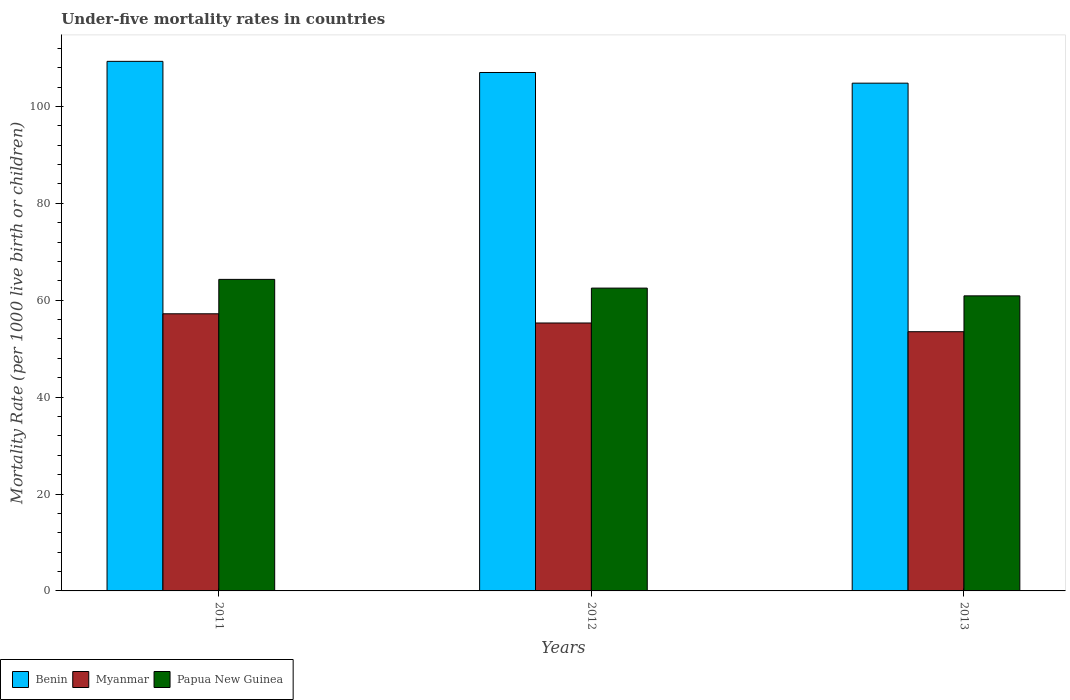How many different coloured bars are there?
Your response must be concise. 3. Are the number of bars on each tick of the X-axis equal?
Your answer should be compact. Yes. How many bars are there on the 2nd tick from the left?
Make the answer very short. 3. How many bars are there on the 3rd tick from the right?
Offer a very short reply. 3. What is the under-five mortality rate in Benin in 2011?
Provide a succinct answer. 109.3. Across all years, what is the maximum under-five mortality rate in Benin?
Keep it short and to the point. 109.3. Across all years, what is the minimum under-five mortality rate in Myanmar?
Your response must be concise. 53.5. In which year was the under-five mortality rate in Papua New Guinea maximum?
Ensure brevity in your answer.  2011. What is the total under-five mortality rate in Papua New Guinea in the graph?
Provide a short and direct response. 187.7. What is the difference between the under-five mortality rate in Benin in 2012 and that in 2013?
Offer a terse response. 2.2. What is the difference between the under-five mortality rate in Papua New Guinea in 2011 and the under-five mortality rate in Myanmar in 2013?
Provide a succinct answer. 10.8. What is the average under-five mortality rate in Papua New Guinea per year?
Make the answer very short. 62.57. In the year 2013, what is the difference between the under-five mortality rate in Papua New Guinea and under-five mortality rate in Benin?
Offer a terse response. -43.9. What is the ratio of the under-five mortality rate in Benin in 2011 to that in 2013?
Ensure brevity in your answer.  1.04. What is the difference between the highest and the second highest under-five mortality rate in Papua New Guinea?
Offer a very short reply. 1.8. What is the difference between the highest and the lowest under-five mortality rate in Papua New Guinea?
Offer a terse response. 3.4. In how many years, is the under-five mortality rate in Benin greater than the average under-five mortality rate in Benin taken over all years?
Offer a terse response. 1. Is the sum of the under-five mortality rate in Myanmar in 2011 and 2012 greater than the maximum under-five mortality rate in Benin across all years?
Keep it short and to the point. Yes. What does the 2nd bar from the left in 2011 represents?
Make the answer very short. Myanmar. What does the 3rd bar from the right in 2013 represents?
Give a very brief answer. Benin. Are all the bars in the graph horizontal?
Offer a terse response. No. Are the values on the major ticks of Y-axis written in scientific E-notation?
Provide a succinct answer. No. Does the graph contain any zero values?
Offer a terse response. No. Does the graph contain grids?
Your response must be concise. No. How many legend labels are there?
Your response must be concise. 3. How are the legend labels stacked?
Provide a short and direct response. Horizontal. What is the title of the graph?
Provide a short and direct response. Under-five mortality rates in countries. Does "Antigua and Barbuda" appear as one of the legend labels in the graph?
Give a very brief answer. No. What is the label or title of the Y-axis?
Provide a succinct answer. Mortality Rate (per 1000 live birth or children). What is the Mortality Rate (per 1000 live birth or children) of Benin in 2011?
Ensure brevity in your answer.  109.3. What is the Mortality Rate (per 1000 live birth or children) of Myanmar in 2011?
Ensure brevity in your answer.  57.2. What is the Mortality Rate (per 1000 live birth or children) of Papua New Guinea in 2011?
Your answer should be very brief. 64.3. What is the Mortality Rate (per 1000 live birth or children) of Benin in 2012?
Make the answer very short. 107. What is the Mortality Rate (per 1000 live birth or children) of Myanmar in 2012?
Provide a short and direct response. 55.3. What is the Mortality Rate (per 1000 live birth or children) of Papua New Guinea in 2012?
Make the answer very short. 62.5. What is the Mortality Rate (per 1000 live birth or children) in Benin in 2013?
Offer a terse response. 104.8. What is the Mortality Rate (per 1000 live birth or children) in Myanmar in 2013?
Offer a terse response. 53.5. What is the Mortality Rate (per 1000 live birth or children) in Papua New Guinea in 2013?
Your response must be concise. 60.9. Across all years, what is the maximum Mortality Rate (per 1000 live birth or children) of Benin?
Your answer should be compact. 109.3. Across all years, what is the maximum Mortality Rate (per 1000 live birth or children) in Myanmar?
Your answer should be very brief. 57.2. Across all years, what is the maximum Mortality Rate (per 1000 live birth or children) of Papua New Guinea?
Make the answer very short. 64.3. Across all years, what is the minimum Mortality Rate (per 1000 live birth or children) in Benin?
Keep it short and to the point. 104.8. Across all years, what is the minimum Mortality Rate (per 1000 live birth or children) of Myanmar?
Keep it short and to the point. 53.5. Across all years, what is the minimum Mortality Rate (per 1000 live birth or children) in Papua New Guinea?
Ensure brevity in your answer.  60.9. What is the total Mortality Rate (per 1000 live birth or children) of Benin in the graph?
Keep it short and to the point. 321.1. What is the total Mortality Rate (per 1000 live birth or children) of Myanmar in the graph?
Your answer should be very brief. 166. What is the total Mortality Rate (per 1000 live birth or children) in Papua New Guinea in the graph?
Keep it short and to the point. 187.7. What is the difference between the Mortality Rate (per 1000 live birth or children) in Myanmar in 2011 and that in 2012?
Keep it short and to the point. 1.9. What is the difference between the Mortality Rate (per 1000 live birth or children) of Myanmar in 2011 and that in 2013?
Your answer should be very brief. 3.7. What is the difference between the Mortality Rate (per 1000 live birth or children) in Myanmar in 2012 and that in 2013?
Provide a succinct answer. 1.8. What is the difference between the Mortality Rate (per 1000 live birth or children) of Benin in 2011 and the Mortality Rate (per 1000 live birth or children) of Papua New Guinea in 2012?
Your response must be concise. 46.8. What is the difference between the Mortality Rate (per 1000 live birth or children) of Benin in 2011 and the Mortality Rate (per 1000 live birth or children) of Myanmar in 2013?
Provide a succinct answer. 55.8. What is the difference between the Mortality Rate (per 1000 live birth or children) in Benin in 2011 and the Mortality Rate (per 1000 live birth or children) in Papua New Guinea in 2013?
Your answer should be very brief. 48.4. What is the difference between the Mortality Rate (per 1000 live birth or children) of Myanmar in 2011 and the Mortality Rate (per 1000 live birth or children) of Papua New Guinea in 2013?
Provide a succinct answer. -3.7. What is the difference between the Mortality Rate (per 1000 live birth or children) in Benin in 2012 and the Mortality Rate (per 1000 live birth or children) in Myanmar in 2013?
Your answer should be compact. 53.5. What is the difference between the Mortality Rate (per 1000 live birth or children) in Benin in 2012 and the Mortality Rate (per 1000 live birth or children) in Papua New Guinea in 2013?
Make the answer very short. 46.1. What is the difference between the Mortality Rate (per 1000 live birth or children) in Myanmar in 2012 and the Mortality Rate (per 1000 live birth or children) in Papua New Guinea in 2013?
Offer a terse response. -5.6. What is the average Mortality Rate (per 1000 live birth or children) in Benin per year?
Your answer should be compact. 107.03. What is the average Mortality Rate (per 1000 live birth or children) of Myanmar per year?
Provide a succinct answer. 55.33. What is the average Mortality Rate (per 1000 live birth or children) in Papua New Guinea per year?
Provide a short and direct response. 62.57. In the year 2011, what is the difference between the Mortality Rate (per 1000 live birth or children) of Benin and Mortality Rate (per 1000 live birth or children) of Myanmar?
Make the answer very short. 52.1. In the year 2012, what is the difference between the Mortality Rate (per 1000 live birth or children) in Benin and Mortality Rate (per 1000 live birth or children) in Myanmar?
Give a very brief answer. 51.7. In the year 2012, what is the difference between the Mortality Rate (per 1000 live birth or children) in Benin and Mortality Rate (per 1000 live birth or children) in Papua New Guinea?
Keep it short and to the point. 44.5. In the year 2012, what is the difference between the Mortality Rate (per 1000 live birth or children) in Myanmar and Mortality Rate (per 1000 live birth or children) in Papua New Guinea?
Offer a terse response. -7.2. In the year 2013, what is the difference between the Mortality Rate (per 1000 live birth or children) in Benin and Mortality Rate (per 1000 live birth or children) in Myanmar?
Your answer should be compact. 51.3. In the year 2013, what is the difference between the Mortality Rate (per 1000 live birth or children) in Benin and Mortality Rate (per 1000 live birth or children) in Papua New Guinea?
Offer a terse response. 43.9. What is the ratio of the Mortality Rate (per 1000 live birth or children) of Benin in 2011 to that in 2012?
Provide a short and direct response. 1.02. What is the ratio of the Mortality Rate (per 1000 live birth or children) of Myanmar in 2011 to that in 2012?
Your answer should be very brief. 1.03. What is the ratio of the Mortality Rate (per 1000 live birth or children) in Papua New Guinea in 2011 to that in 2012?
Your answer should be very brief. 1.03. What is the ratio of the Mortality Rate (per 1000 live birth or children) of Benin in 2011 to that in 2013?
Your answer should be compact. 1.04. What is the ratio of the Mortality Rate (per 1000 live birth or children) in Myanmar in 2011 to that in 2013?
Offer a terse response. 1.07. What is the ratio of the Mortality Rate (per 1000 live birth or children) of Papua New Guinea in 2011 to that in 2013?
Make the answer very short. 1.06. What is the ratio of the Mortality Rate (per 1000 live birth or children) in Benin in 2012 to that in 2013?
Keep it short and to the point. 1.02. What is the ratio of the Mortality Rate (per 1000 live birth or children) of Myanmar in 2012 to that in 2013?
Your answer should be compact. 1.03. What is the ratio of the Mortality Rate (per 1000 live birth or children) in Papua New Guinea in 2012 to that in 2013?
Your response must be concise. 1.03. What is the difference between the highest and the second highest Mortality Rate (per 1000 live birth or children) of Myanmar?
Keep it short and to the point. 1.9. What is the difference between the highest and the lowest Mortality Rate (per 1000 live birth or children) of Benin?
Provide a short and direct response. 4.5. What is the difference between the highest and the lowest Mortality Rate (per 1000 live birth or children) of Papua New Guinea?
Ensure brevity in your answer.  3.4. 